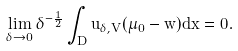<formula> <loc_0><loc_0><loc_500><loc_500>\lim _ { \delta \to 0 } \delta ^ { - \frac { 1 } { 2 } } \int _ { D } u _ { \delta , V } ( \mu _ { 0 } - w ) d x = 0 .</formula> 